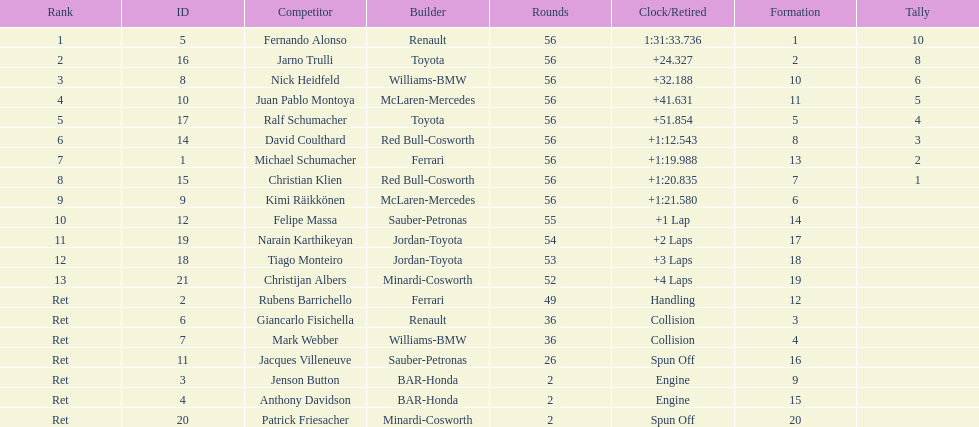Jarno trulli was not french but what nationality? Italian. 